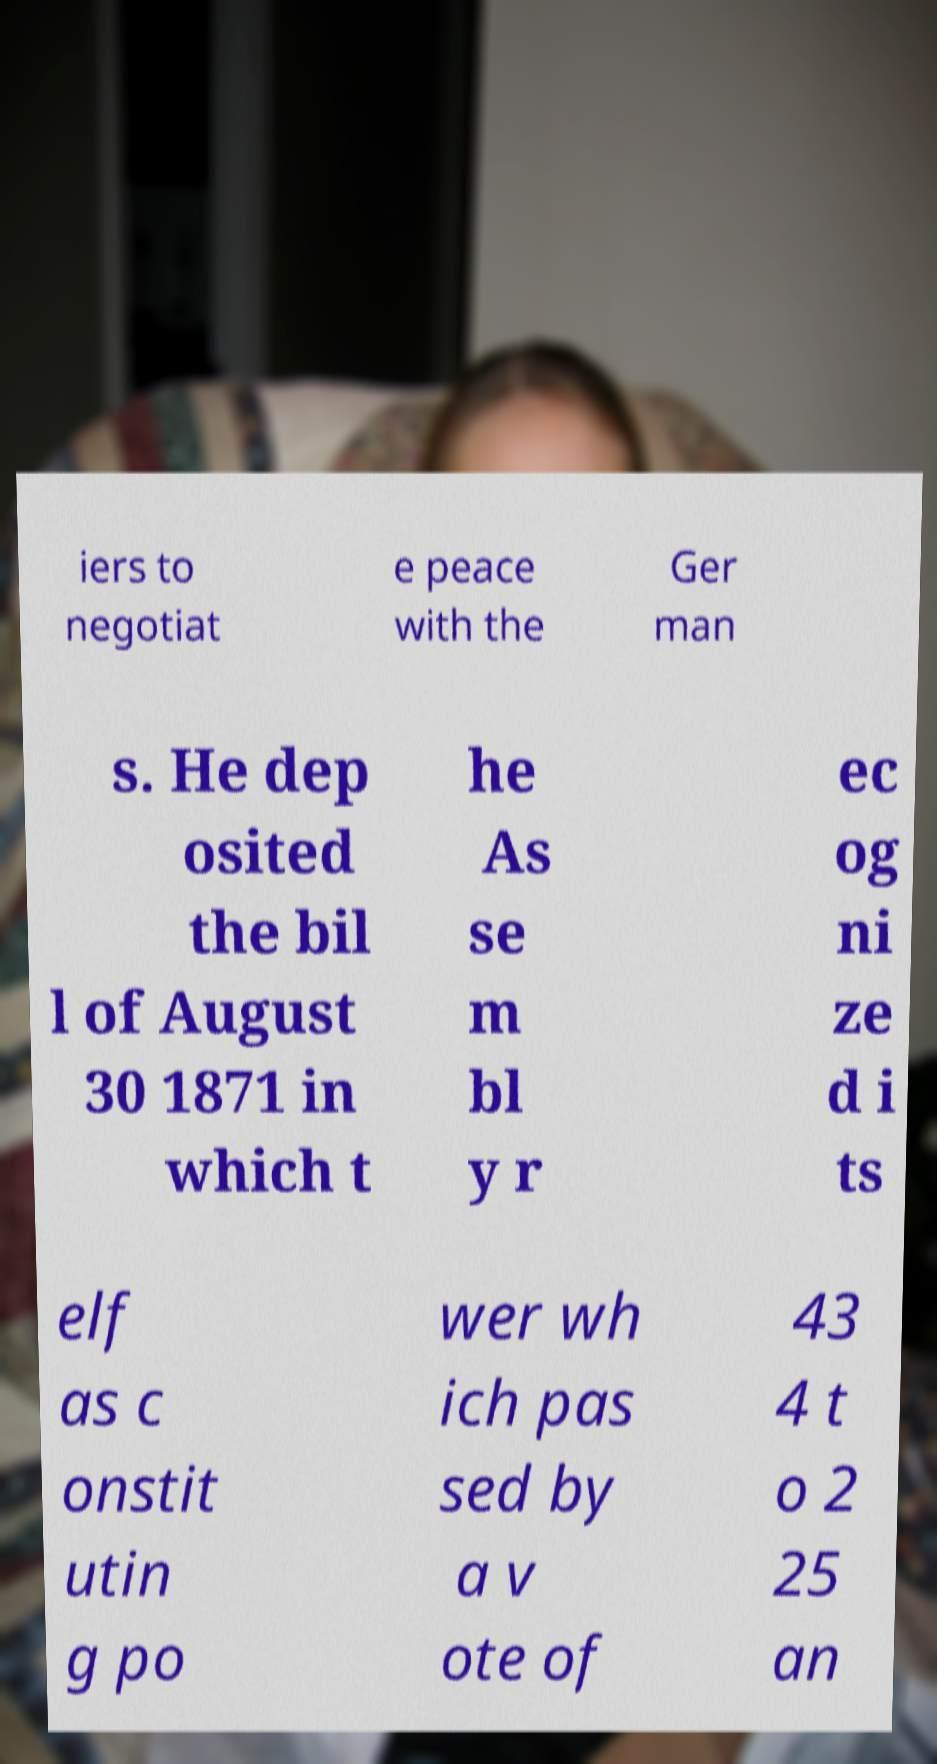Can you accurately transcribe the text from the provided image for me? iers to negotiat e peace with the Ger man s. He dep osited the bil l of August 30 1871 in which t he As se m bl y r ec og ni ze d i ts elf as c onstit utin g po wer wh ich pas sed by a v ote of 43 4 t o 2 25 an 